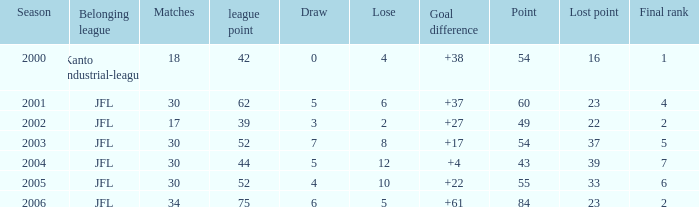Would you mind parsing the complete table? {'header': ['Season', 'Belonging league', 'Matches', 'league point', 'Draw', 'Lose', 'Goal difference', 'Point', 'Lost point', 'Final rank'], 'rows': [['2000', 'Kanto industrial-league', '18', '42', '0', '4', '+38', '54', '16', '1'], ['2001', 'JFL', '30', '62', '5', '6', '+37', '60', '23', '4'], ['2002', 'JFL', '17', '39', '3', '2', '+27', '49', '22', '2'], ['2003', 'JFL', '30', '52', '7', '8', '+17', '54', '37', '5'], ['2004', 'JFL', '30', '44', '5', '12', '+4', '43', '39', '7'], ['2005', 'JFL', '30', '52', '4', '10', '+22', '55', '33', '6'], ['2006', 'JFL', '34', '75', '6', '5', '+61', '84', '23', '2']]} Tell me the highest point with lost point being 33 and league point less than 52 None. 